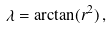Convert formula to latex. <formula><loc_0><loc_0><loc_500><loc_500>\lambda = \arctan ( r ^ { 2 } ) \, ,</formula> 